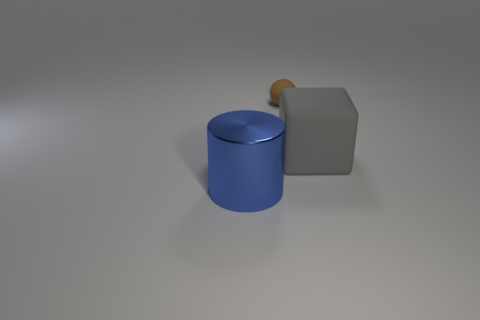What color is the thing in front of the matte thing that is to the right of the tiny brown rubber object?
Keep it short and to the point. Blue. There is a brown object that is to the left of the large thing behind the large blue object; what number of cylinders are in front of it?
Provide a succinct answer. 1. There is a large shiny cylinder; are there any tiny brown matte balls behind it?
Make the answer very short. Yes. What number of blocks are big gray things or large shiny things?
Ensure brevity in your answer.  1. What number of things are both in front of the sphere and behind the blue metallic thing?
Provide a short and direct response. 1. Are there the same number of small spheres that are in front of the big blue cylinder and blue cylinders that are behind the sphere?
Your answer should be compact. Yes. There is a rubber object right of the thing behind the thing that is right of the ball; what shape is it?
Your response must be concise. Cube. What is the material of the thing that is both in front of the small brown rubber ball and behind the cylinder?
Offer a very short reply. Rubber. Is the number of large purple matte cubes less than the number of blue shiny things?
Ensure brevity in your answer.  Yes. Do the large matte object and the large thing on the left side of the small brown matte thing have the same shape?
Your answer should be compact. No. 